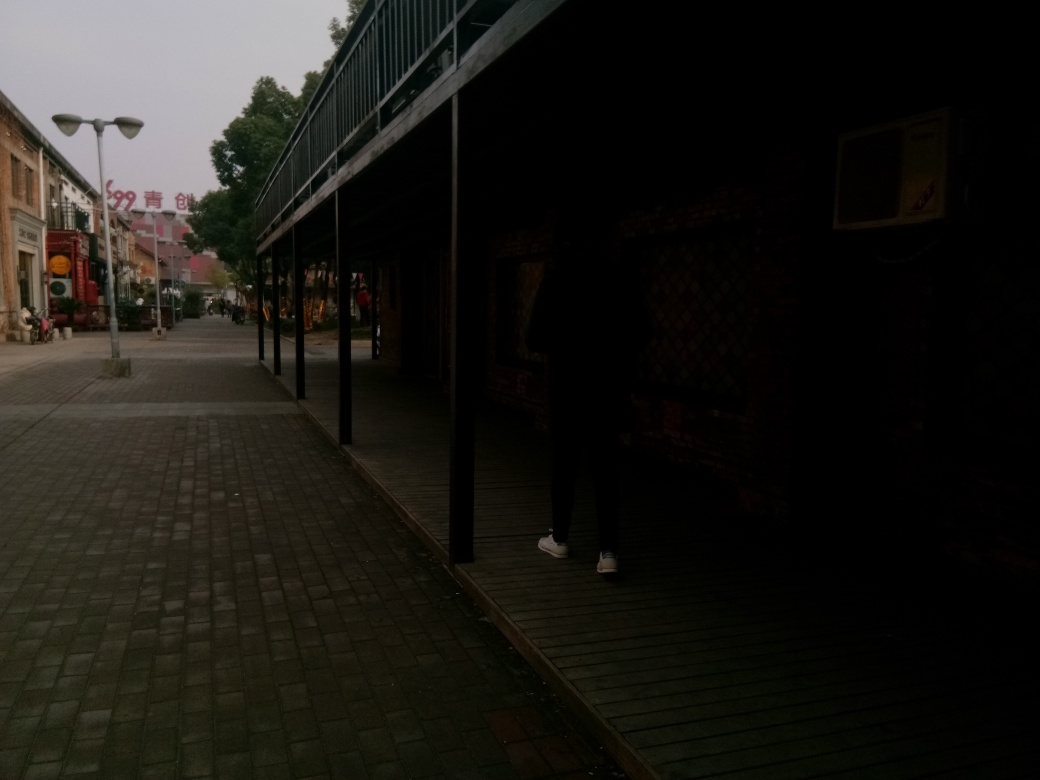Are the texture details of street lamps clear? Although the street lamps can be distinguished, the texture details are not entirely clear due to the image's overall low light conditions and distance from the lamps. To accurately assess the texture, a closer perspective or better lighting would be beneficial. 